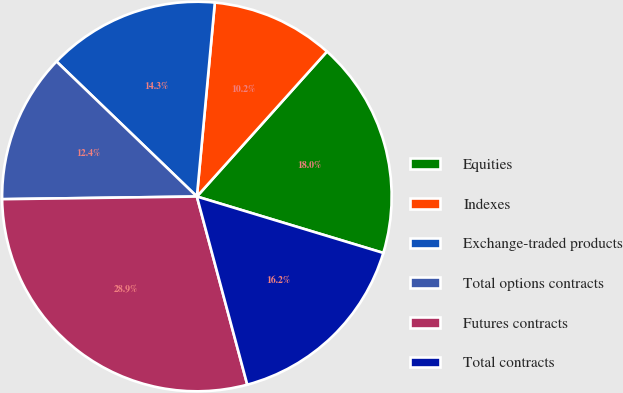Convert chart. <chart><loc_0><loc_0><loc_500><loc_500><pie_chart><fcel>Equities<fcel>Indexes<fcel>Exchange-traded products<fcel>Total options contracts<fcel>Futures contracts<fcel>Total contracts<nl><fcel>18.04%<fcel>10.17%<fcel>14.28%<fcel>12.41%<fcel>28.95%<fcel>16.16%<nl></chart> 